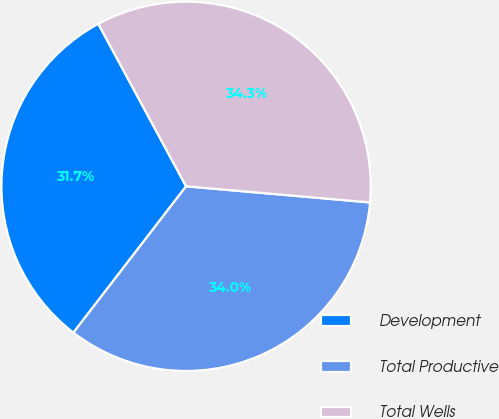<chart> <loc_0><loc_0><loc_500><loc_500><pie_chart><fcel>Development<fcel>Total Productive<fcel>Total Wells<nl><fcel>31.67%<fcel>34.05%<fcel>34.28%<nl></chart> 